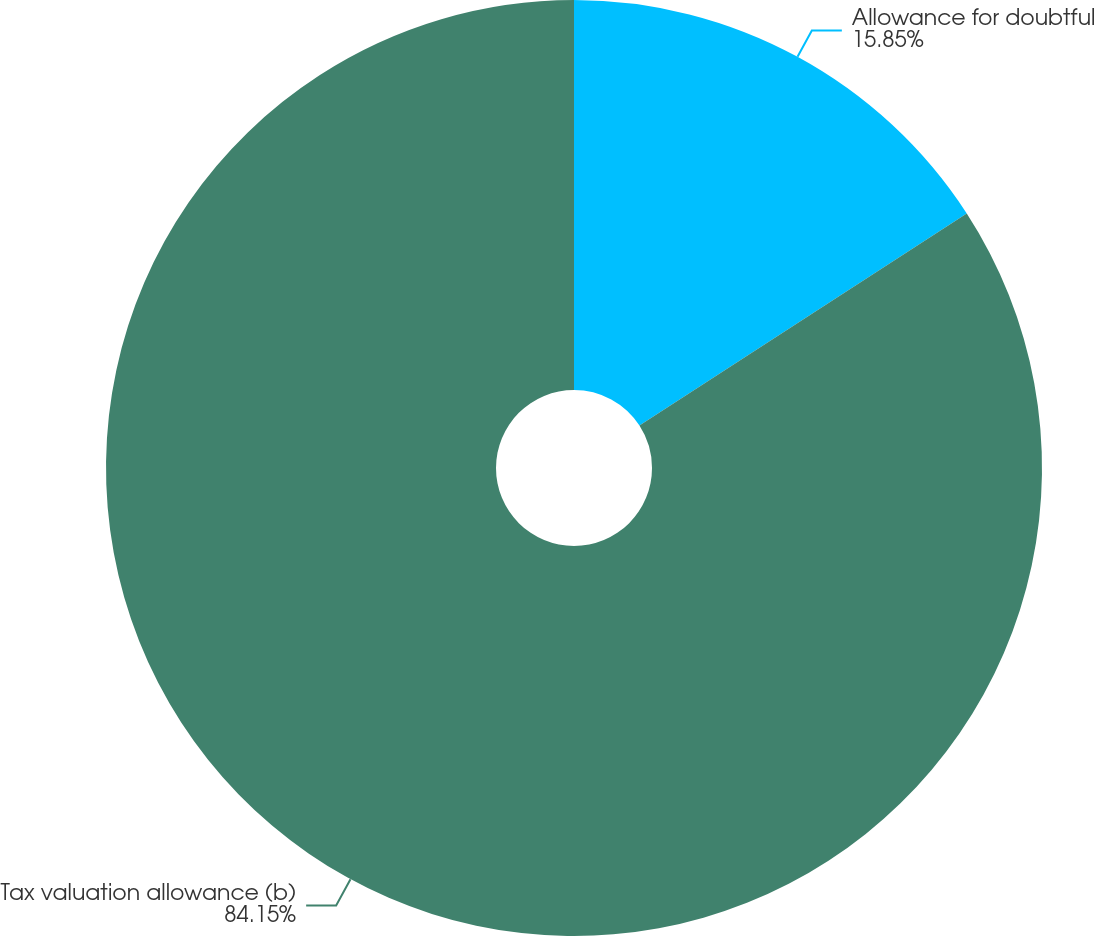Convert chart to OTSL. <chart><loc_0><loc_0><loc_500><loc_500><pie_chart><fcel>Allowance for doubtful<fcel>Tax valuation allowance (b)<nl><fcel>15.85%<fcel>84.15%<nl></chart> 